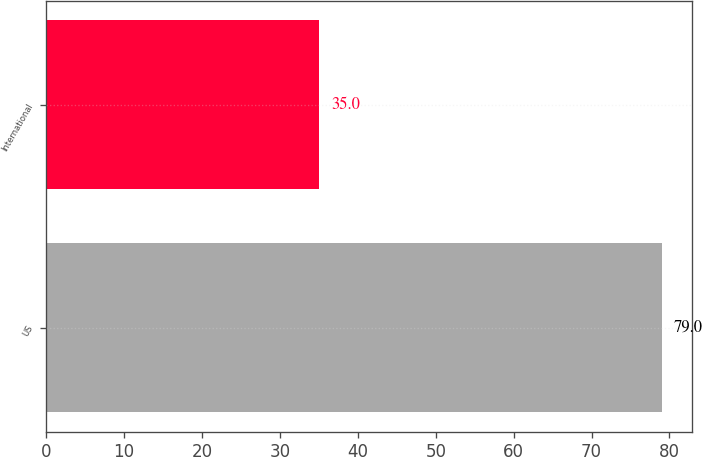<chart> <loc_0><loc_0><loc_500><loc_500><bar_chart><fcel>US<fcel>International<nl><fcel>79<fcel>35<nl></chart> 